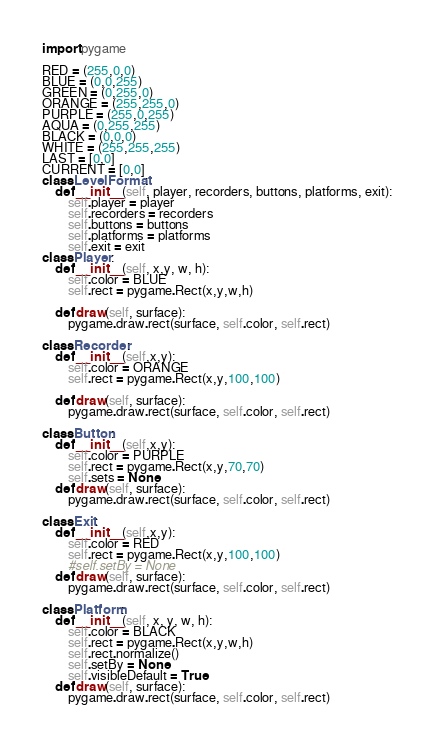<code> <loc_0><loc_0><loc_500><loc_500><_Python_>import pygame

RED = (255,0,0)
BLUE = (0,0,255)
GREEN = (0,255,0)
ORANGE = (255,255,0)
PURPLE = (255,0,255)
AQUA = (0,255,255)
BLACK = (0,0,0)
WHITE = (255,255,255)
LAST = [0,0]
CURRENT = [0,0]
class LevelFormat:
    def __init__(self, player, recorders, buttons, platforms, exit):
        self.player = player
        self.recorders = recorders
        self.buttons = buttons
        self.platforms = platforms
        self.exit = exit
class Player:
    def __init__(self, x,y, w, h):
        self.color = BLUE
        self.rect = pygame.Rect(x,y,w,h)

    def draw(self, surface):
        pygame.draw.rect(surface, self.color, self.rect)

class Recorder:
    def __init__(self,x,y):
        self.color = ORANGE
        self.rect = pygame.Rect(x,y,100,100)

    def draw(self, surface):
        pygame.draw.rect(surface, self.color, self.rect)

class Button:
    def __init__(self,x,y):
        self.color = PURPLE
        self.rect = pygame.Rect(x,y,70,70)
        self.sets = None
    def draw(self, surface):
        pygame.draw.rect(surface, self.color, self.rect)

class Exit:
    def __init__(self,x,y):
        self.color = RED
        self.rect = pygame.Rect(x,y,100,100)
        #self.setBy = None
    def draw(self, surface):
        pygame.draw.rect(surface, self.color, self.rect)

class Platform:
    def __init__(self, x, y, w, h):
        self.color = BLACK
        self.rect = pygame.Rect(x,y,w,h)
        self.rect.normalize()
        self.setBy = None
        self.visibleDefault = True
    def draw(self, surface):
        pygame.draw.rect(surface, self.color, self.rect)

</code> 